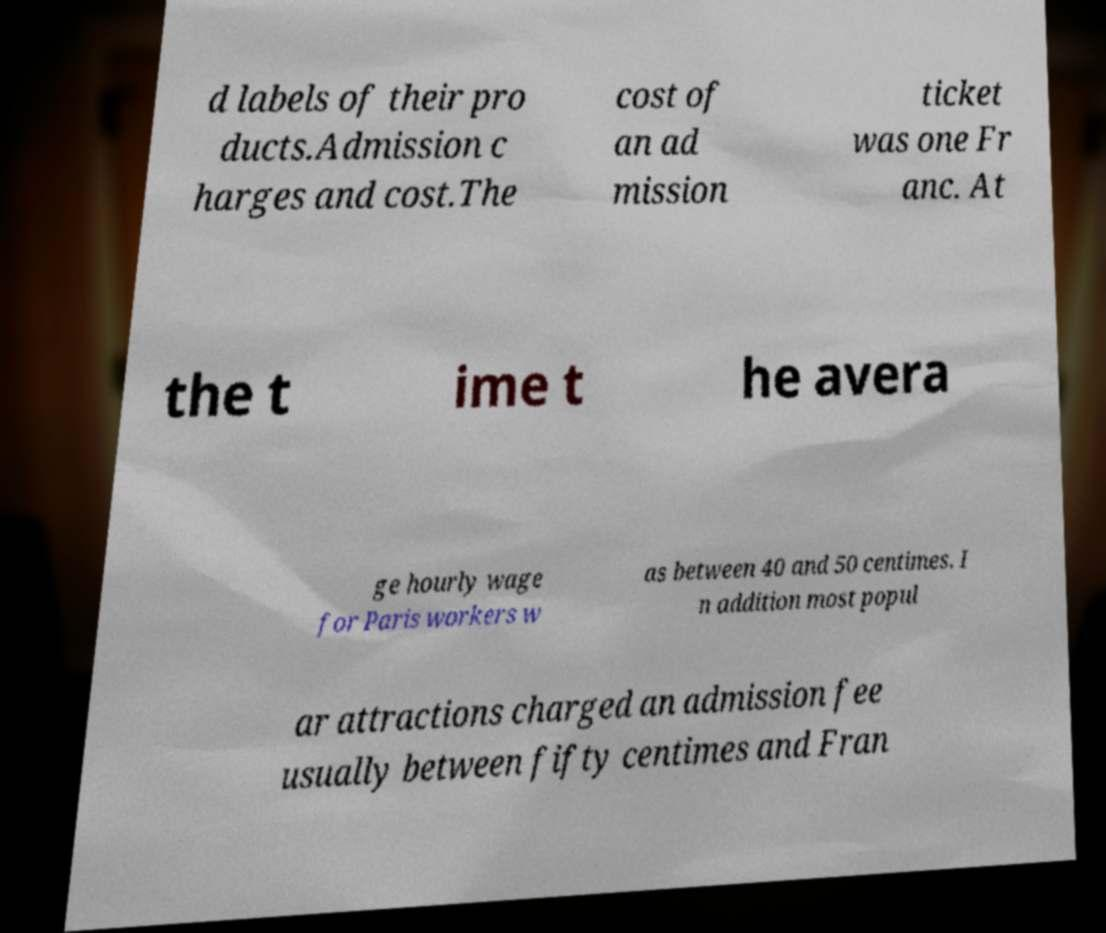Please read and relay the text visible in this image. What does it say? d labels of their pro ducts.Admission c harges and cost.The cost of an ad mission ticket was one Fr anc. At the t ime t he avera ge hourly wage for Paris workers w as between 40 and 50 centimes. I n addition most popul ar attractions charged an admission fee usually between fifty centimes and Fran 